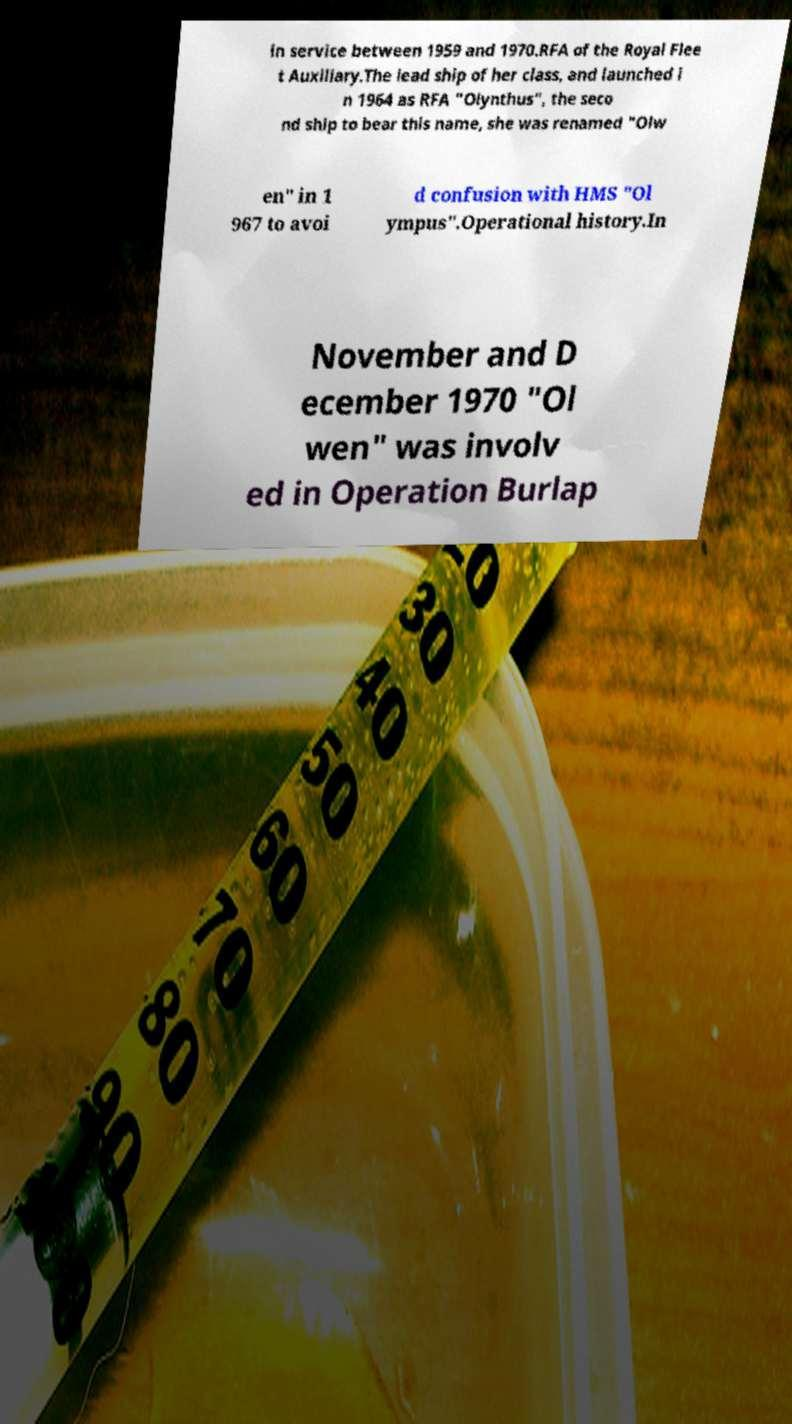Please identify and transcribe the text found in this image. in service between 1959 and 1970.RFA of the Royal Flee t Auxiliary.The lead ship of her class, and launched i n 1964 as RFA "Olynthus", the seco nd ship to bear this name, she was renamed "Olw en" in 1 967 to avoi d confusion with HMS "Ol ympus".Operational history.In November and D ecember 1970 "Ol wen" was involv ed in Operation Burlap 